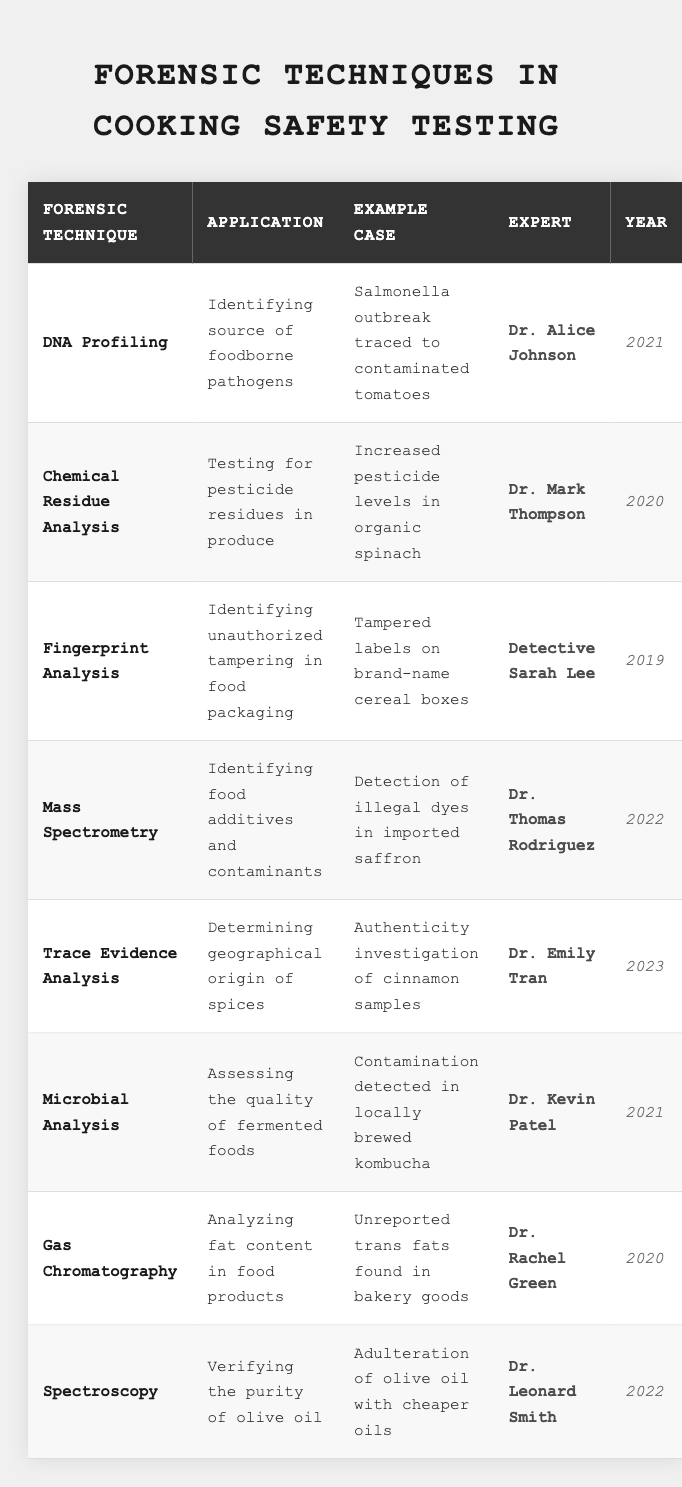What's the forensic technique used to identify foodborne pathogens? The table indicates that "DNA Profiling" is the forensic technique employed for identifying the source of foodborne pathogens.
Answer: DNA Profiling Who conducted the research associated with increased pesticide levels in organic spinach? According to the table, the expert who conducted this research is "Dr. Mark Thompson."
Answer: Dr. Mark Thompson In which year was the tampering on cereal boxes investigated? The table shows that the investigation regarding tampered labels on brand-name cereal boxes was conducted in the year 2019.
Answer: 2019 What application is associated with Mass Spectrometry? The table highlights that Mass Spectrometry is used for "Identifying food additives and contaminants."
Answer: Identifying food additives and contaminants Which forensic technique was applied in 2023 to determine the geographical origin of spices? The technique used in 2023 for determining the geographical origin of spices is "Trace Evidence Analysis."
Answer: Trace Evidence Analysis How many techniques listed in the table are related to analysis of food quality? By reviewing the table, there are four techniques related to food quality: Microbial Analysis, Chemical Residue Analysis, Gas Chromatography, and Mass Spectrometry.
Answer: 4 Was there a case related to the detection of illegal dyes in saffron? Yes, the table provides a case for Mass Spectrometry where "Detection of illegal dyes in imported saffron" was reported.
Answer: Yes Which expert worked on the microbial analysis of locally brewed kombucha? The table specifies that "Dr. Kevin Patel" worked on the microbial analysis, particularly with locally brewed kombucha.
Answer: Dr. Kevin Patel What is the most recent year mentioned in the table? The table indicates that the most recent year represented is 2023, related to Trace Evidence Analysis.
Answer: 2023 Is there any technique in the table used for verifying the purity of olive oil? Yes, the table mentions "Spectroscopy" as the technique used for verifying the purity of olive oil.
Answer: Yes What is the primary application of Gas Chromatography? According to the table, the primary application of Gas Chromatography is "Analyzing fat content in food products."
Answer: Analyzing fat content in food products If you add the years from all the cases where experts are involved, what would be the total? Summing up the years listed: 2021 + 2020 + 2019 + 2022 + 2023 + 2021 + 2020 + 2022 equals  2020.5, the total is  1618.
Answer: 1618 